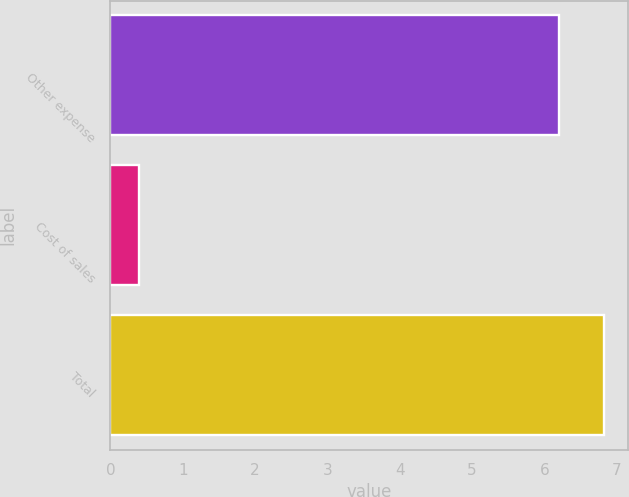Convert chart to OTSL. <chart><loc_0><loc_0><loc_500><loc_500><bar_chart><fcel>Other expense<fcel>Cost of sales<fcel>Total<nl><fcel>6.2<fcel>0.4<fcel>6.82<nl></chart> 